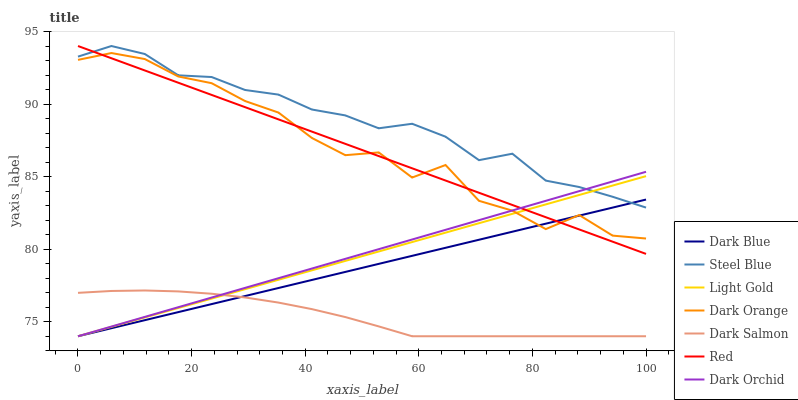Does Dark Salmon have the minimum area under the curve?
Answer yes or no. Yes. Does Steel Blue have the maximum area under the curve?
Answer yes or no. Yes. Does Dark Orchid have the minimum area under the curve?
Answer yes or no. No. Does Dark Orchid have the maximum area under the curve?
Answer yes or no. No. Is Dark Orchid the smoothest?
Answer yes or no. Yes. Is Dark Orange the roughest?
Answer yes or no. Yes. Is Dark Salmon the smoothest?
Answer yes or no. No. Is Dark Salmon the roughest?
Answer yes or no. No. Does Dark Salmon have the lowest value?
Answer yes or no. Yes. Does Steel Blue have the lowest value?
Answer yes or no. No. Does Red have the highest value?
Answer yes or no. Yes. Does Dark Orchid have the highest value?
Answer yes or no. No. Is Dark Orange less than Steel Blue?
Answer yes or no. Yes. Is Dark Orange greater than Dark Salmon?
Answer yes or no. Yes. Does Dark Orchid intersect Light Gold?
Answer yes or no. Yes. Is Dark Orchid less than Light Gold?
Answer yes or no. No. Is Dark Orchid greater than Light Gold?
Answer yes or no. No. Does Dark Orange intersect Steel Blue?
Answer yes or no. No. 